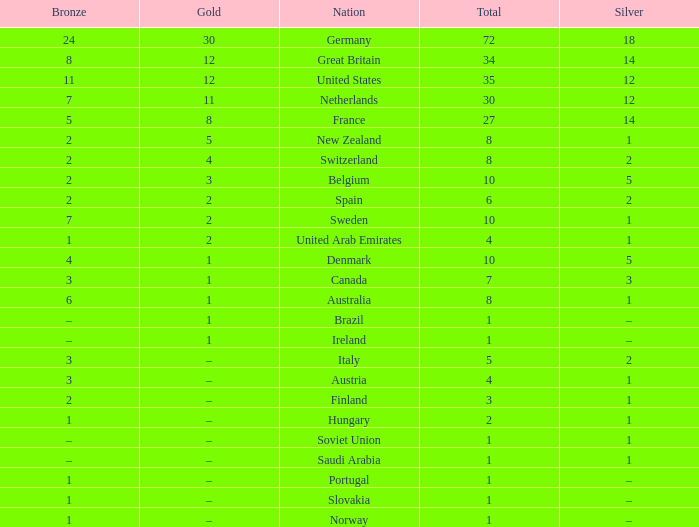What is Gold, when Bronze is 11? 12.0. 